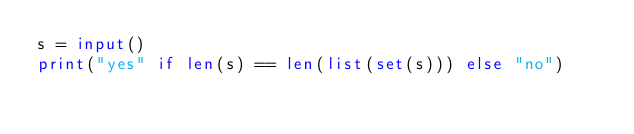<code> <loc_0><loc_0><loc_500><loc_500><_Python_>s = input()
print("yes" if len(s) == len(list(set(s))) else "no")</code> 